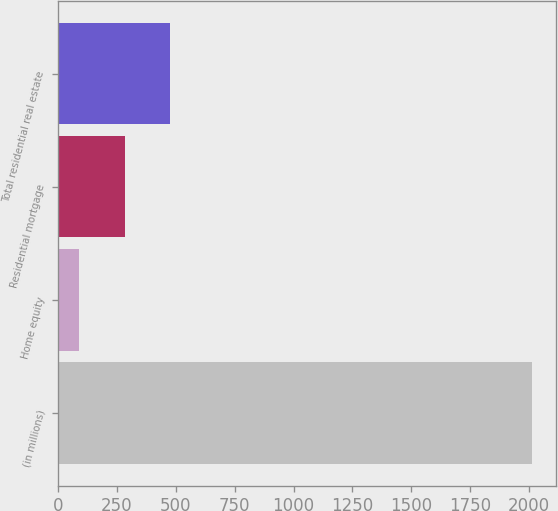<chart> <loc_0><loc_0><loc_500><loc_500><bar_chart><fcel>(in millions)<fcel>Home equity<fcel>Residential mortgage<fcel>Total residential real estate<nl><fcel>2014<fcel>90<fcel>282.4<fcel>474.8<nl></chart> 